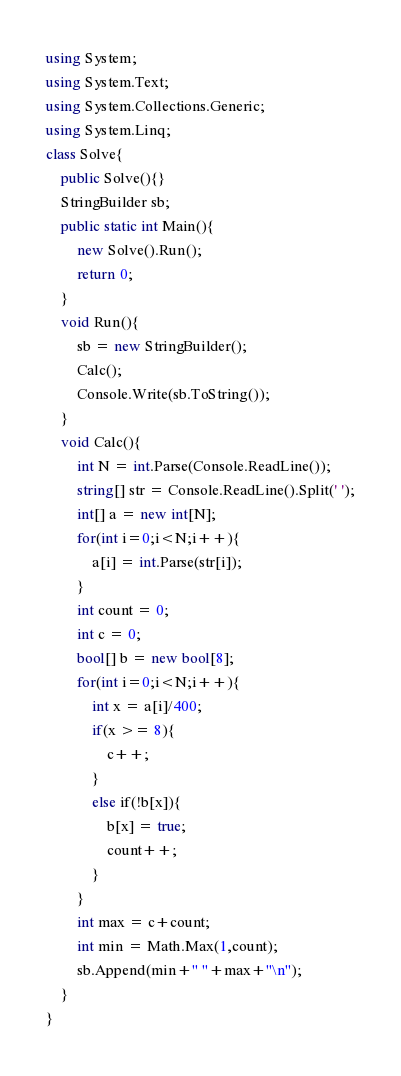<code> <loc_0><loc_0><loc_500><loc_500><_C#_>using System;
using System.Text;
using System.Collections.Generic;
using System.Linq;
class Solve{
    public Solve(){}
    StringBuilder sb;
    public static int Main(){
        new Solve().Run();
        return 0;
    }
    void Run(){
        sb = new StringBuilder();
        Calc();
        Console.Write(sb.ToString());
    }
    void Calc(){
        int N = int.Parse(Console.ReadLine());
        string[] str = Console.ReadLine().Split(' ');
        int[] a = new int[N];
        for(int i=0;i<N;i++){
            a[i] = int.Parse(str[i]);
        }
        int count = 0;
        int c = 0;
        bool[] b = new bool[8];
        for(int i=0;i<N;i++){
            int x = a[i]/400;
            if(x >= 8){
                c++;
            }
            else if(!b[x]){
                b[x] = true;
                count++;
            }
        }
        int max = c+count;
        int min = Math.Max(1,count);
        sb.Append(min+" "+max+"\n");
    }
}</code> 